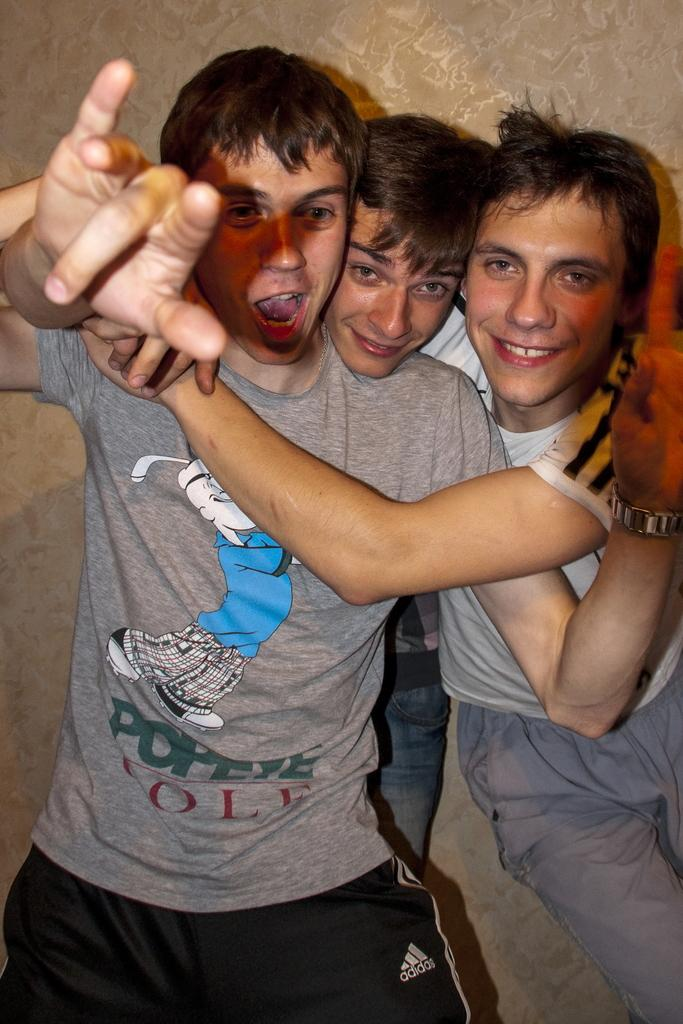Provide a one-sentence caption for the provided image. Three guys are embracing and one of them is wearing a Popeye shirt. 